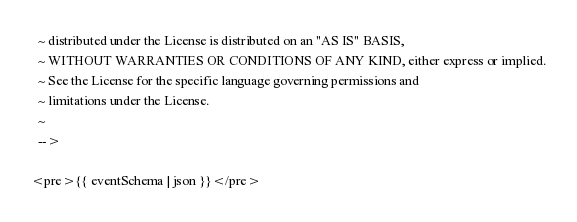<code> <loc_0><loc_0><loc_500><loc_500><_HTML_>  ~ distributed under the License is distributed on an "AS IS" BASIS,
  ~ WITHOUT WARRANTIES OR CONDITIONS OF ANY KIND, either express or implied.
  ~ See the License for the specific language governing permissions and
  ~ limitations under the License.
  ~
  -->

<pre>{{ eventSchema | json }}</pre></code> 